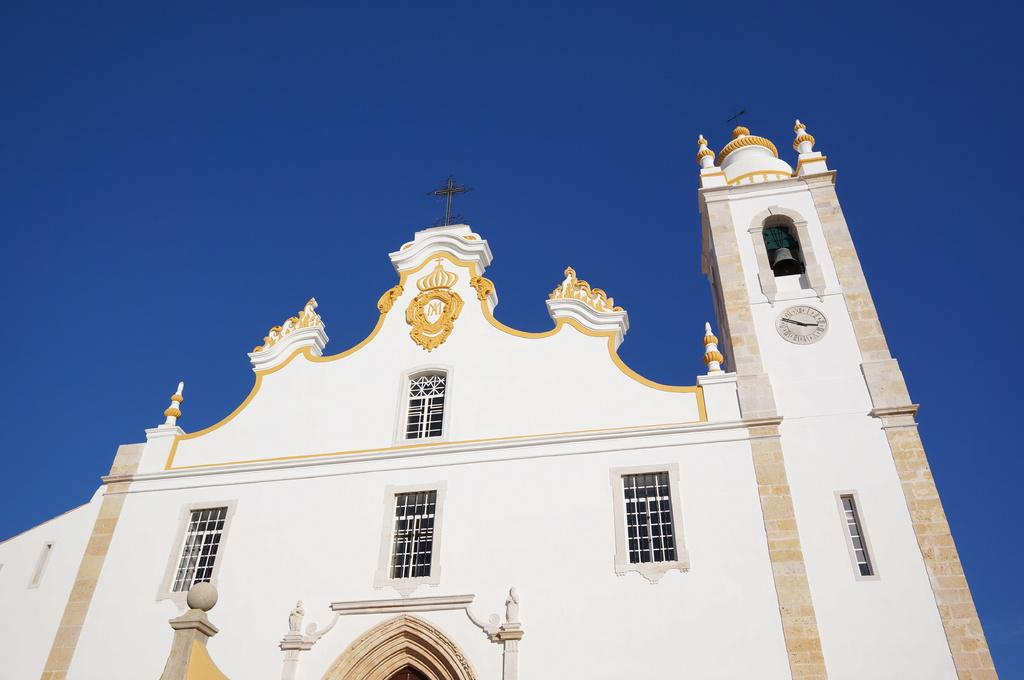What is the main subject in the center of the image? There is a building in the center of the image. What is the color of the building? The building is white in color. Can you describe any specific features of the building? There is a clock on the wall on the right side of the building. What type of ear is visible on the building in the image? There is no ear present on the building in the image. Is there a pencil being used to draw the building in the image? The image is a photograph, not a drawing, and there is no pencil visible in the image. 